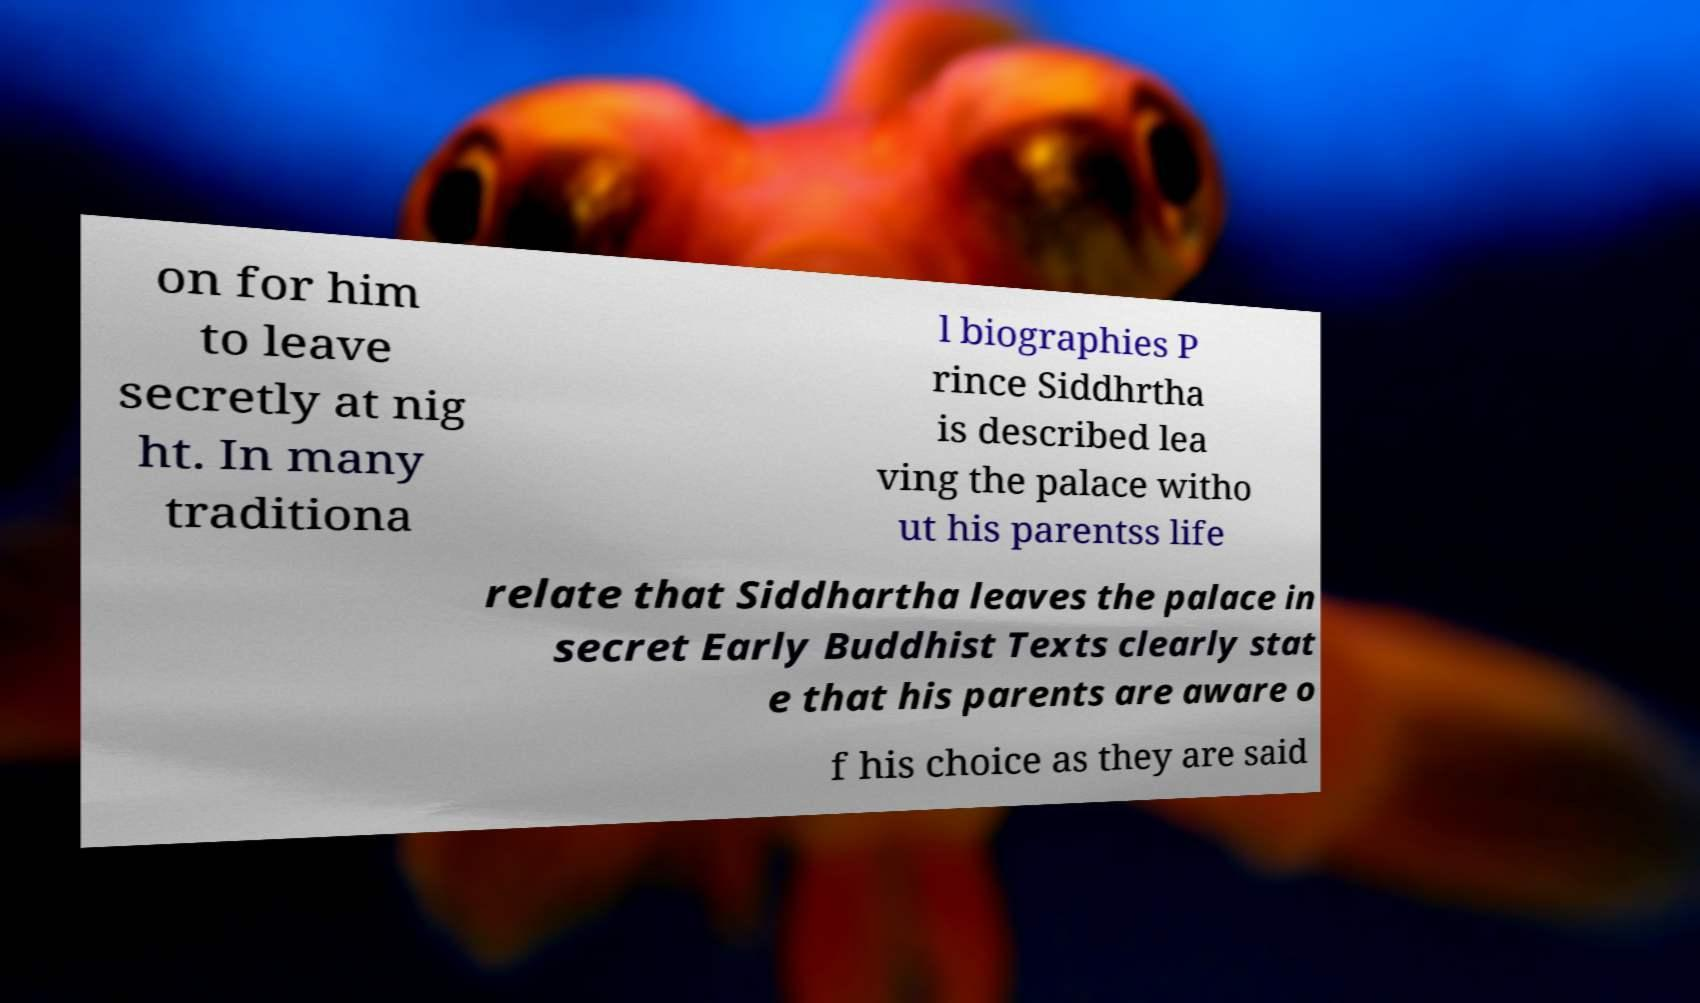Could you extract and type out the text from this image? on for him to leave secretly at nig ht. In many traditiona l biographies P rince Siddhrtha is described lea ving the palace witho ut his parentss life relate that Siddhartha leaves the palace in secret Early Buddhist Texts clearly stat e that his parents are aware o f his choice as they are said 